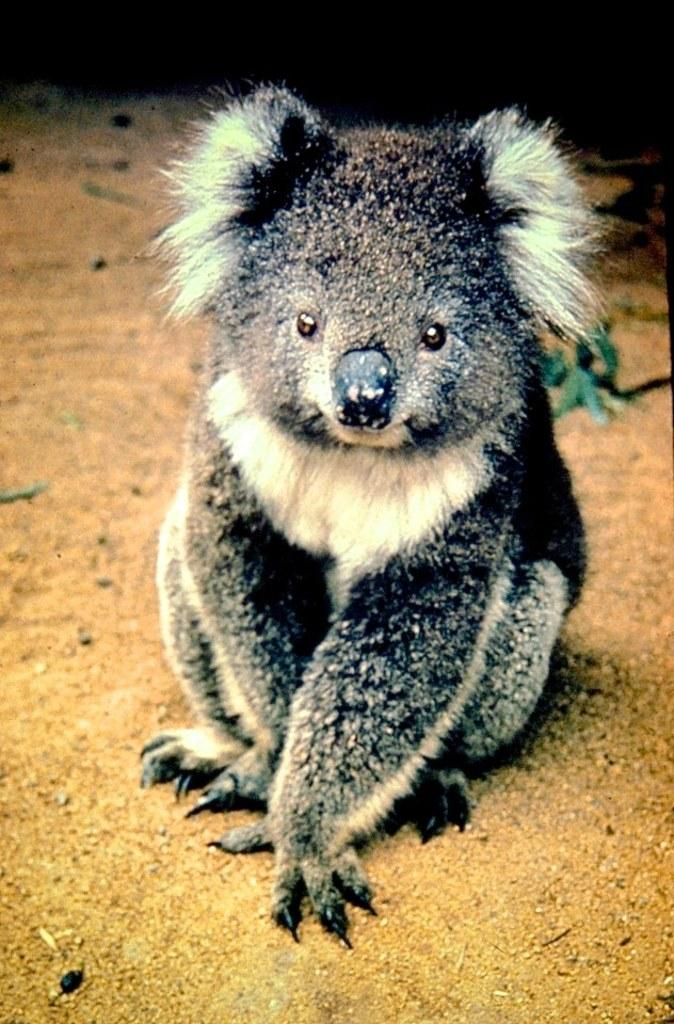What type of creature is present in the image? There is an animal in the image. Can you describe the color pattern of the animal? The animal is black and white in color. What is the title of the painting in the image? There is no painting or title present in the image; it features an animal. 